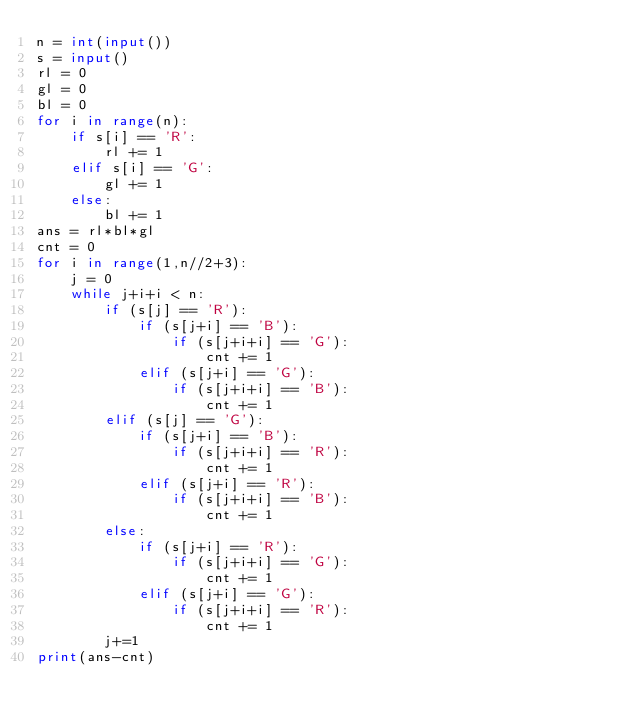Convert code to text. <code><loc_0><loc_0><loc_500><loc_500><_Python_>n = int(input())
s = input()
rl = 0
gl = 0
bl = 0
for i in range(n):
	if s[i] == 'R':
		rl += 1
	elif s[i] == 'G':
		gl += 1
	else:
		bl += 1
ans = rl*bl*gl
cnt = 0
for i in range(1,n//2+3):
	j = 0
	while j+i+i < n:
		if (s[j] == 'R'):
			if (s[j+i] == 'B'):
				if (s[j+i+i] == 'G'):
					cnt += 1
			elif (s[j+i] == 'G'):
				if (s[j+i+i] == 'B'):
					cnt += 1
		elif (s[j] == 'G'):
			if (s[j+i] == 'B'):
				if (s[j+i+i] == 'R'):
					cnt += 1
			elif (s[j+i] == 'R'):
				if (s[j+i+i] == 'B'):
					cnt += 1
		else:
			if (s[j+i] == 'R'):
				if (s[j+i+i] == 'G'):
					cnt += 1
			elif (s[j+i] == 'G'):
				if (s[j+i+i] == 'R'):
					cnt += 1
		j+=1
print(ans-cnt)</code> 